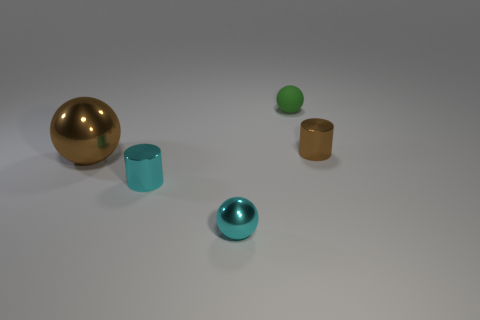There is a metal cylinder that is the same color as the large object; what size is it?
Provide a short and direct response. Small. The metallic ball that is the same size as the brown shiny cylinder is what color?
Provide a short and direct response. Cyan. There is a small cylinder that is behind the tiny cyan metallic cylinder; is its color the same as the large shiny object?
Your response must be concise. Yes. Are there any other things that have the same color as the small matte object?
Your answer should be very brief. No. What is the shape of the tiny shiny object that is in front of the cylinder left of the tiny cyan sphere?
Provide a succinct answer. Sphere. Is the number of tiny blue metallic objects greater than the number of large brown metal things?
Offer a terse response. No. What number of metal objects are both in front of the large brown metallic object and to the right of the small cyan shiny cylinder?
Keep it short and to the point. 1. How many large metal spheres are to the right of the tiny cylinder that is to the right of the small rubber sphere?
Your response must be concise. 0. How many objects are small things behind the brown ball or brown objects on the left side of the cyan cylinder?
Give a very brief answer. 3. What is the material of the other large object that is the same shape as the matte object?
Your answer should be very brief. Metal. 